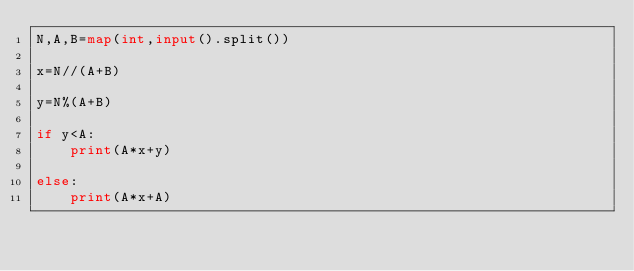Convert code to text. <code><loc_0><loc_0><loc_500><loc_500><_Python_>N,A,B=map(int,input().split())

x=N//(A+B)

y=N%(A+B)

if y<A:
    print(A*x+y)
    
else:
    print(A*x+A)</code> 